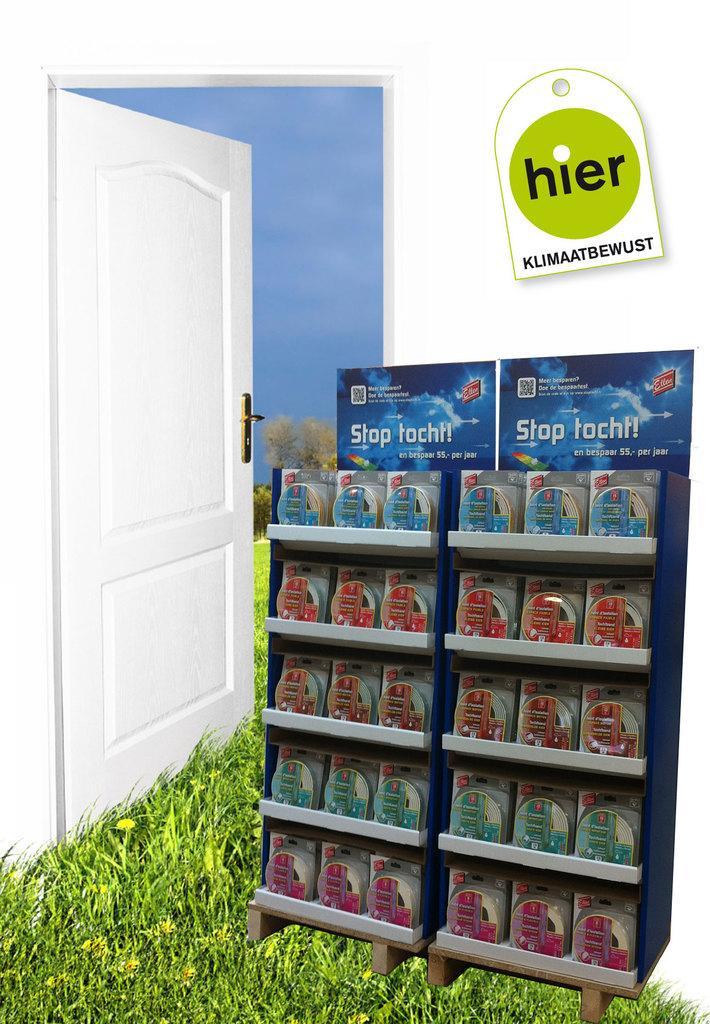In one or two sentences, can you explain what this image depicts? In this picture I can see there are sachets arranged here and there is a door and there is white wall in the backdrop. 